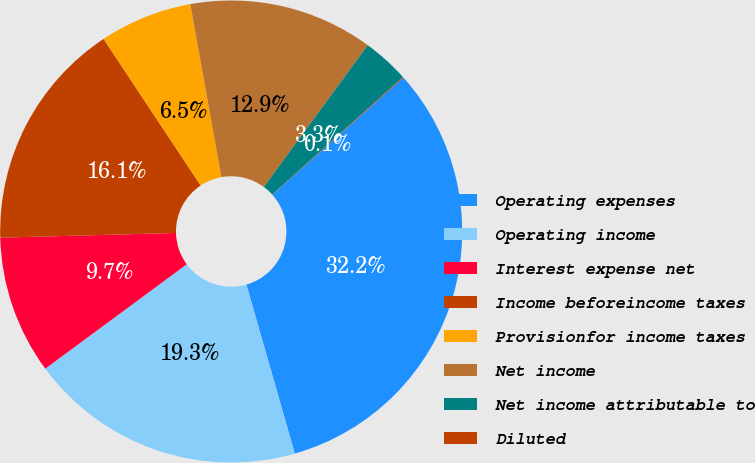Convert chart to OTSL. <chart><loc_0><loc_0><loc_500><loc_500><pie_chart><fcel>Operating expenses<fcel>Operating income<fcel>Interest expense net<fcel>Income beforeincome taxes<fcel>Provisionfor income taxes<fcel>Net income<fcel>Net income attributable to<fcel>Diluted<nl><fcel>32.17%<fcel>19.32%<fcel>9.69%<fcel>16.11%<fcel>6.48%<fcel>12.9%<fcel>3.27%<fcel>0.05%<nl></chart> 